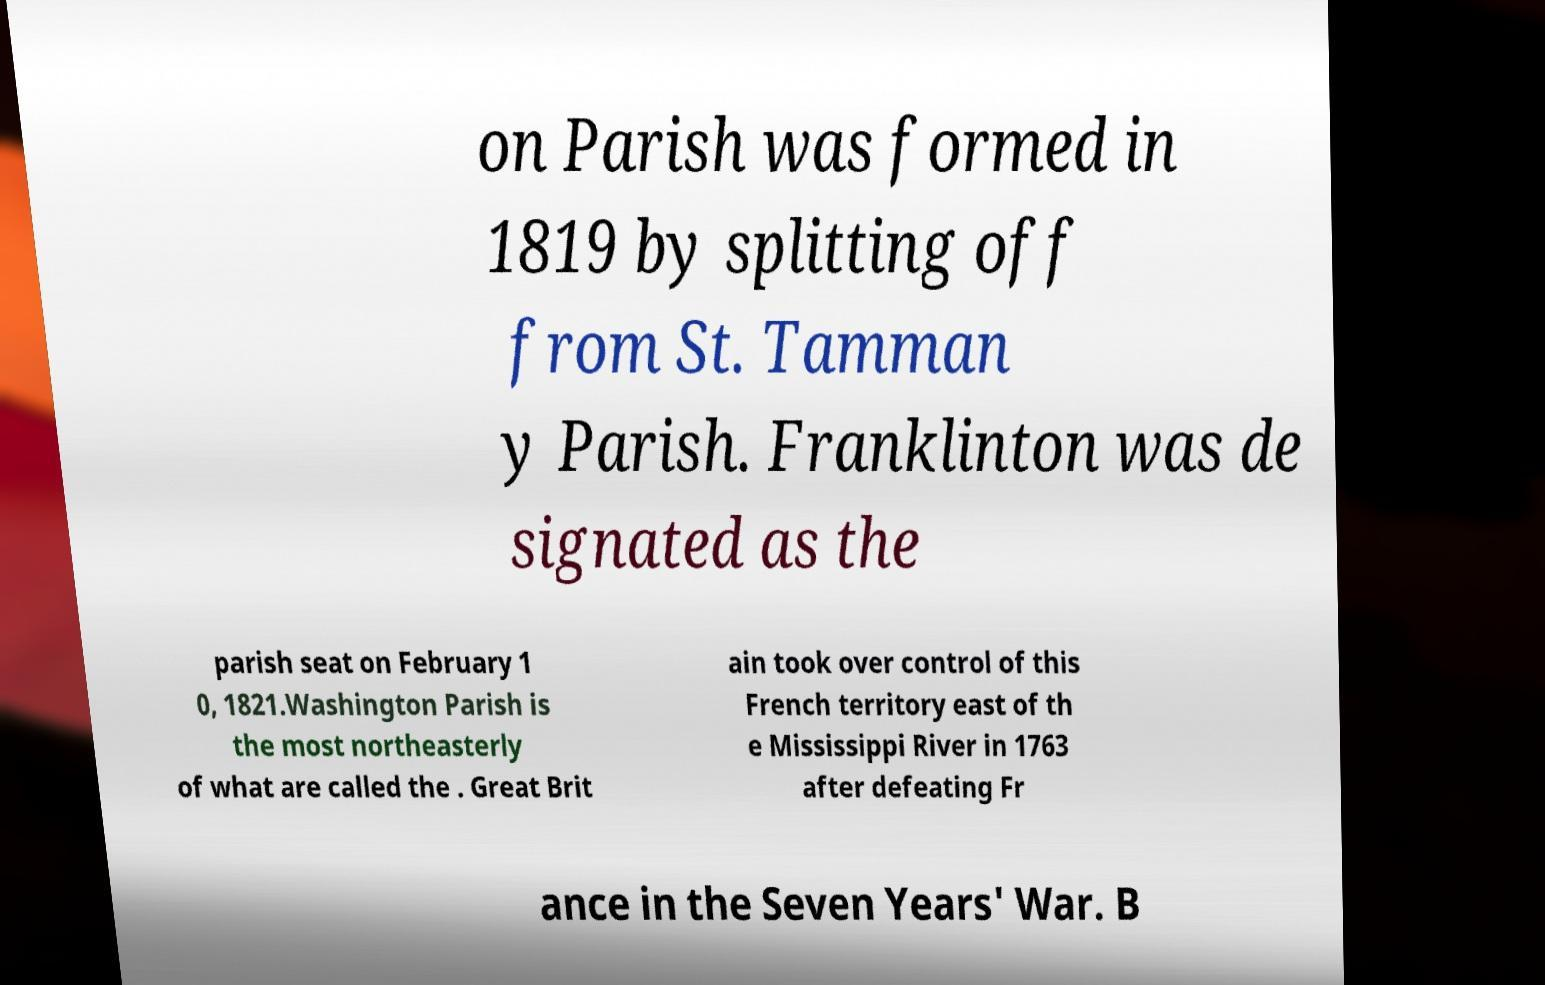Can you accurately transcribe the text from the provided image for me? on Parish was formed in 1819 by splitting off from St. Tamman y Parish. Franklinton was de signated as the parish seat on February 1 0, 1821.Washington Parish is the most northeasterly of what are called the . Great Brit ain took over control of this French territory east of th e Mississippi River in 1763 after defeating Fr ance in the Seven Years' War. B 